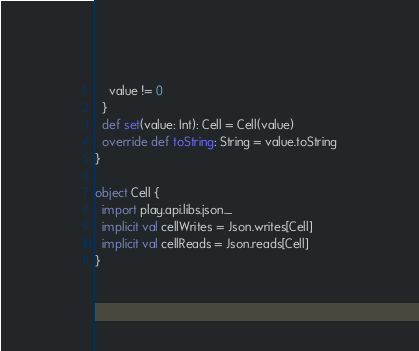<code> <loc_0><loc_0><loc_500><loc_500><_Scala_>    value != 0
  }
  def set(value: Int): Cell = Cell(value)
  override def toString: String = value.toString
}

object Cell {
  import play.api.libs.json._
  implicit val cellWrites = Json.writes[Cell]
  implicit val cellReads = Json.reads[Cell]
}
</code> 